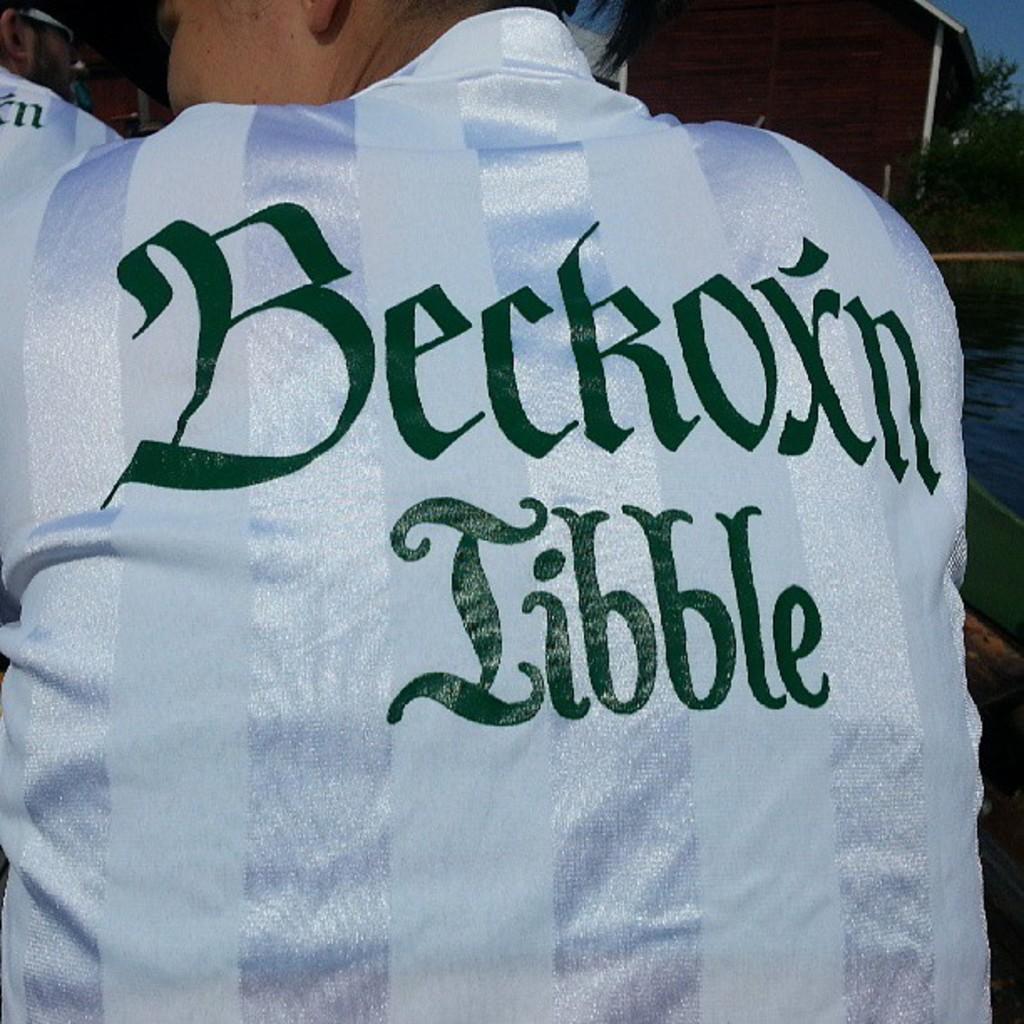What is the name of the jersey?
Your answer should be very brief. Beckoxn libble. 